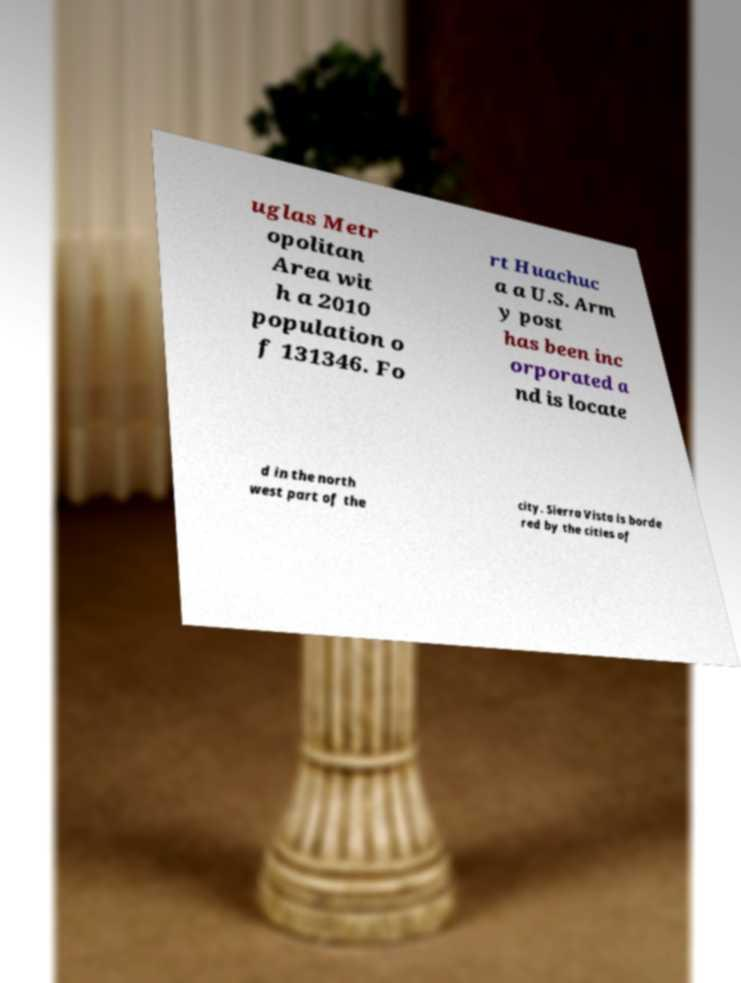For documentation purposes, I need the text within this image transcribed. Could you provide that? uglas Metr opolitan Area wit h a 2010 population o f 131346. Fo rt Huachuc a a U.S. Arm y post has been inc orporated a nd is locate d in the north west part of the city. Sierra Vista is borde red by the cities of 